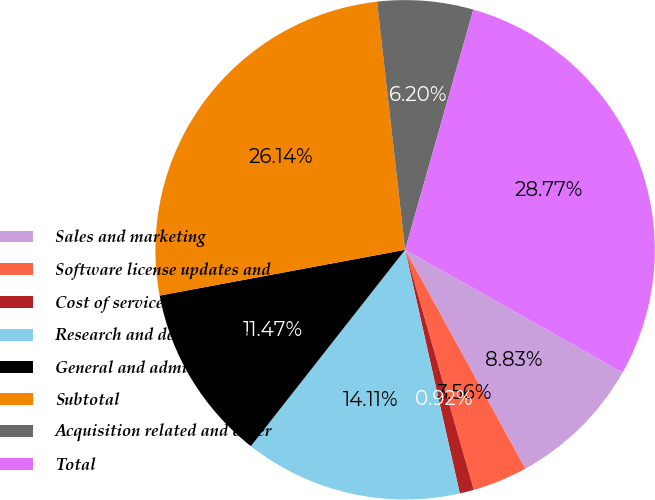Convert chart. <chart><loc_0><loc_0><loc_500><loc_500><pie_chart><fcel>Sales and marketing<fcel>Software license updates and<fcel>Cost of services<fcel>Research and development<fcel>General and administrative<fcel>Subtotal<fcel>Acquisition related and other<fcel>Total<nl><fcel>8.83%<fcel>3.56%<fcel>0.92%<fcel>14.11%<fcel>11.47%<fcel>26.14%<fcel>6.2%<fcel>28.77%<nl></chart> 